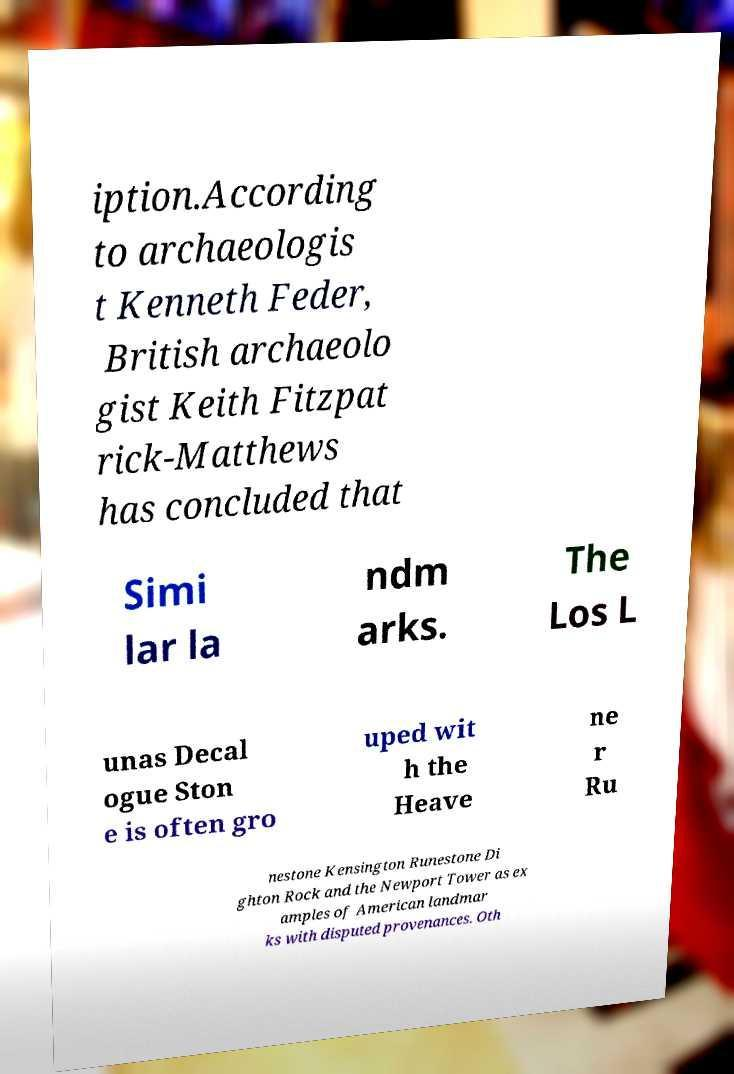There's text embedded in this image that I need extracted. Can you transcribe it verbatim? iption.According to archaeologis t Kenneth Feder, British archaeolo gist Keith Fitzpat rick-Matthews has concluded that Simi lar la ndm arks. The Los L unas Decal ogue Ston e is often gro uped wit h the Heave ne r Ru nestone Kensington Runestone Di ghton Rock and the Newport Tower as ex amples of American landmar ks with disputed provenances. Oth 